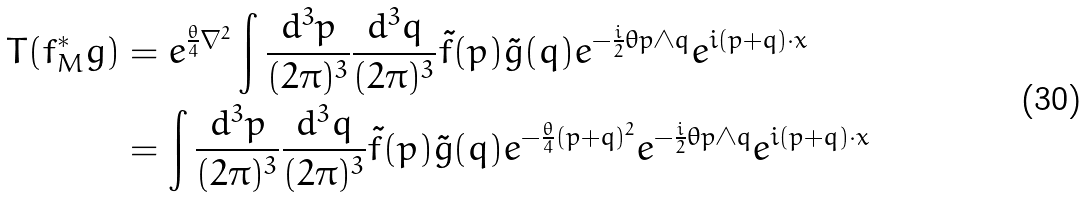<formula> <loc_0><loc_0><loc_500><loc_500>T ( f ^ { * } _ { M } g ) & = e ^ { \frac { \theta } { 4 } \nabla ^ { 2 } } \int \frac { d ^ { 3 } p } { ( 2 \pi ) ^ { 3 } } \frac { d ^ { 3 } q } { ( 2 \pi ) ^ { 3 } } \tilde { f } ( p ) \tilde { g } ( q ) e ^ { - \frac { i } { 2 } \theta p \wedge q } e ^ { i ( p + q ) \cdot x } \\ & = \int \frac { d ^ { 3 } p } { ( 2 \pi ) ^ { 3 } } \frac { d ^ { 3 } q } { ( 2 \pi ) ^ { 3 } } \tilde { f } ( p ) \tilde { g } ( q ) e ^ { - \frac { \theta } { 4 } ( p + q ) ^ { 2 } } e ^ { - \frac { i } { 2 } \theta p \wedge q } e ^ { i ( p + q ) \cdot x }</formula> 